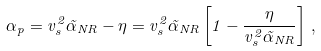Convert formula to latex. <formula><loc_0><loc_0><loc_500><loc_500>\alpha _ { p } = v _ { s } ^ { 2 } \tilde { \alpha } _ { N R } - \eta = v _ { s } ^ { 2 } \tilde { \alpha } _ { N R } \left [ 1 - \frac { \eta } { v _ { s } ^ { 2 } \tilde { \alpha } _ { N R } } \right ] \, ,</formula> 